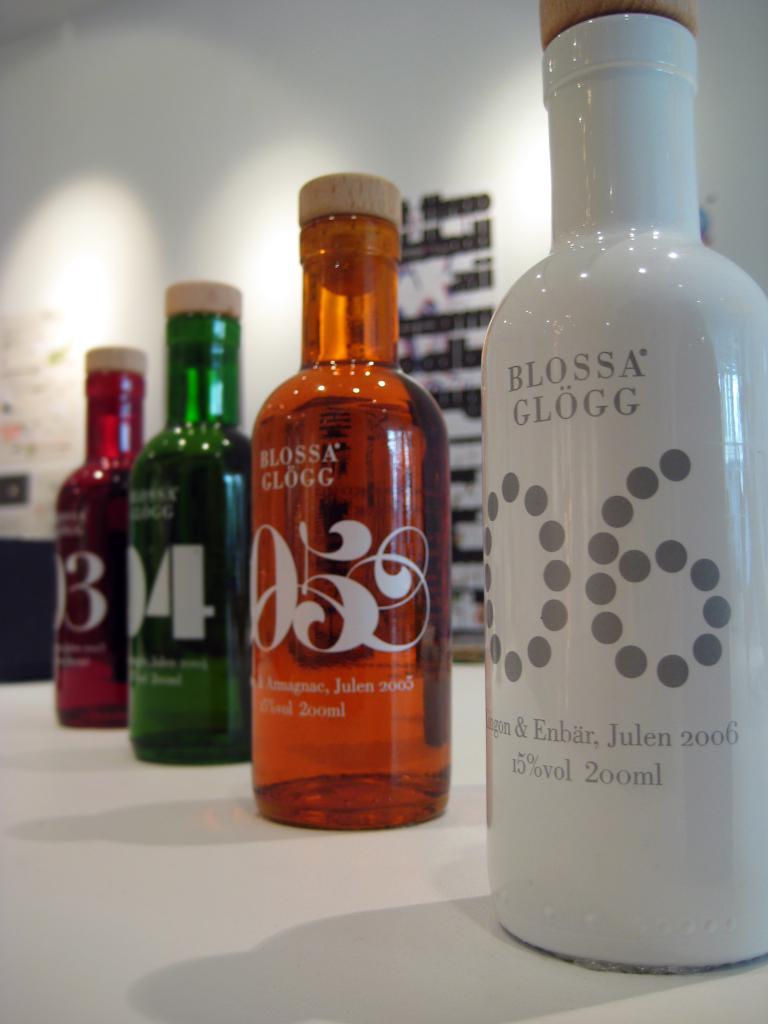What is the alcohol volume of blossa glogg?
Keep it short and to the point. 15%. What is the number of the orange bottle?
Ensure brevity in your answer.  05. 